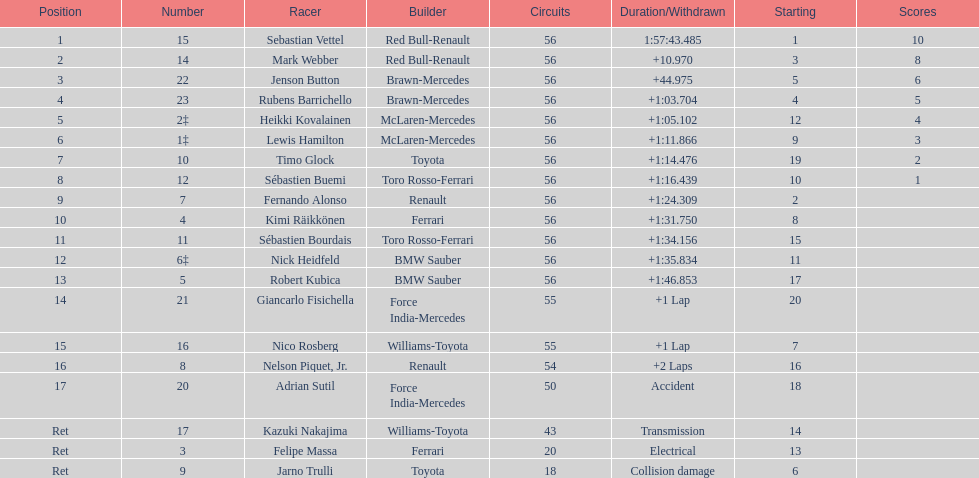How many drivers did not finish 56 laps? 7. 